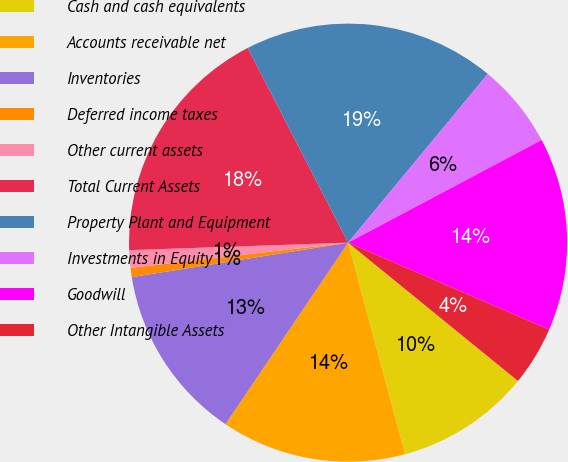Convert chart. <chart><loc_0><loc_0><loc_500><loc_500><pie_chart><fcel>Cash and cash equivalents<fcel>Accounts receivable net<fcel>Inventories<fcel>Deferred income taxes<fcel>Other current assets<fcel>Total Current Assets<fcel>Property Plant and Equipment<fcel>Investments in Equity<fcel>Goodwill<fcel>Other Intangible Assets<nl><fcel>9.94%<fcel>13.64%<fcel>13.03%<fcel>0.68%<fcel>1.29%<fcel>17.97%<fcel>18.58%<fcel>6.23%<fcel>14.26%<fcel>4.38%<nl></chart> 